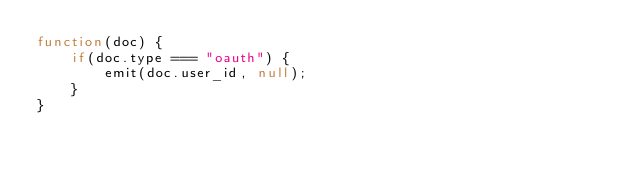Convert code to text. <code><loc_0><loc_0><loc_500><loc_500><_JavaScript_>function(doc) {
    if(doc.type === "oauth") {
        emit(doc.user_id, null);
    }
}
</code> 